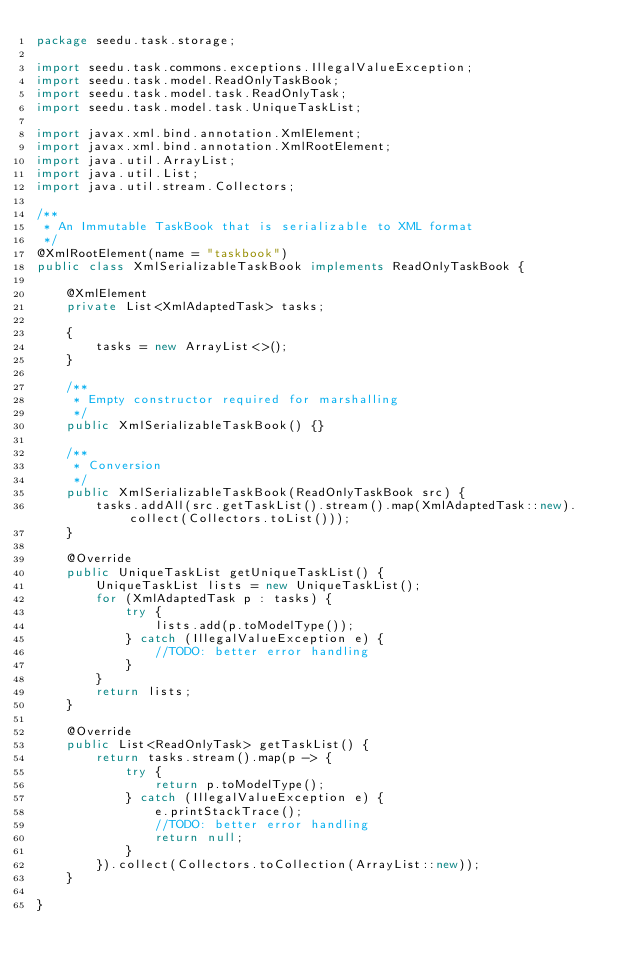Convert code to text. <code><loc_0><loc_0><loc_500><loc_500><_Java_>package seedu.task.storage;

import seedu.task.commons.exceptions.IllegalValueException;
import seedu.task.model.ReadOnlyTaskBook;
import seedu.task.model.task.ReadOnlyTask;
import seedu.task.model.task.UniqueTaskList;

import javax.xml.bind.annotation.XmlElement;
import javax.xml.bind.annotation.XmlRootElement;
import java.util.ArrayList;
import java.util.List;
import java.util.stream.Collectors;

/**
 * An Immutable TaskBook that is serializable to XML format
 */
@XmlRootElement(name = "taskbook")
public class XmlSerializableTaskBook implements ReadOnlyTaskBook {

    @XmlElement
    private List<XmlAdaptedTask> tasks;

    {
        tasks = new ArrayList<>();
    }

    /**
     * Empty constructor required for marshalling
     */
    public XmlSerializableTaskBook() {}

    /**
     * Conversion
     */
    public XmlSerializableTaskBook(ReadOnlyTaskBook src) {
        tasks.addAll(src.getTaskList().stream().map(XmlAdaptedTask::new).collect(Collectors.toList()));
    }

    @Override
    public UniqueTaskList getUniqueTaskList() {
        UniqueTaskList lists = new UniqueTaskList();
        for (XmlAdaptedTask p : tasks) {
            try {
                lists.add(p.toModelType());
            } catch (IllegalValueException e) {
                //TODO: better error handling
            }
        }
        return lists;
    }

    @Override
    public List<ReadOnlyTask> getTaskList() {
        return tasks.stream().map(p -> {
            try {
                return p.toModelType();
            } catch (IllegalValueException e) {
                e.printStackTrace();
                //TODO: better error handling
                return null;
            }
        }).collect(Collectors.toCollection(ArrayList::new));
    }

}
</code> 